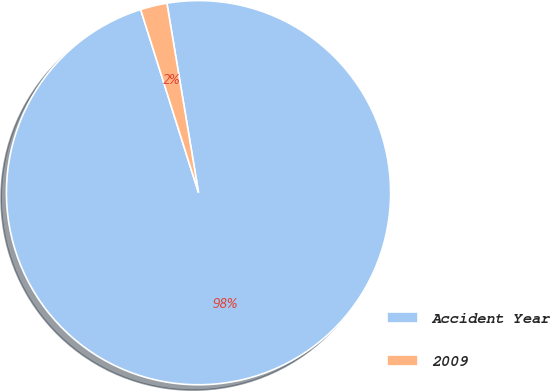Convert chart to OTSL. <chart><loc_0><loc_0><loc_500><loc_500><pie_chart><fcel>Accident Year<fcel>2009<nl><fcel>97.76%<fcel>2.24%<nl></chart> 